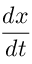<formula> <loc_0><loc_0><loc_500><loc_500>\frac { d x } { d t }</formula> 